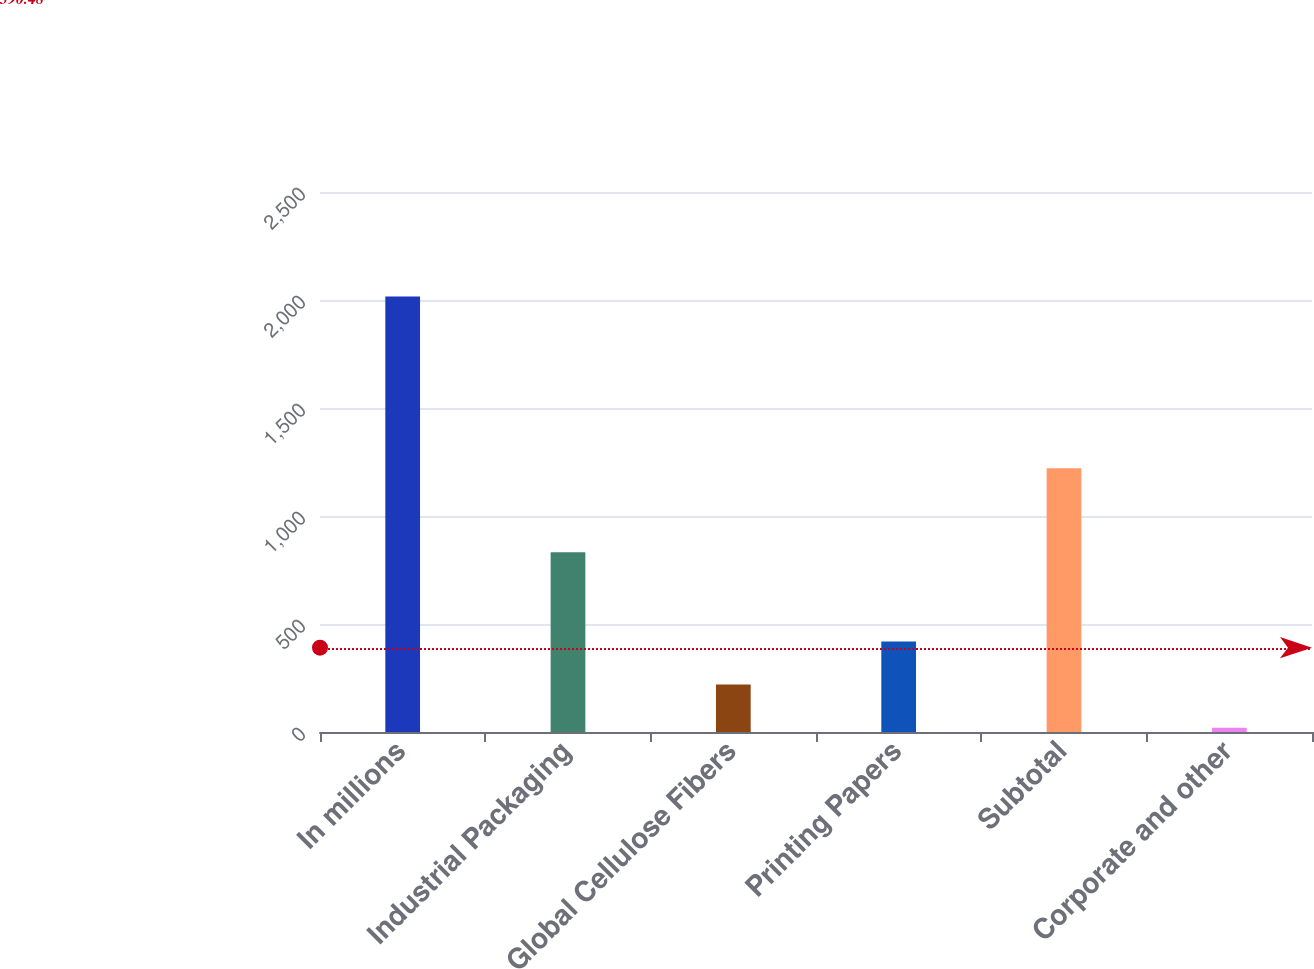<chart> <loc_0><loc_0><loc_500><loc_500><bar_chart><fcel>In millions<fcel>Industrial Packaging<fcel>Global Cellulose Fibers<fcel>Printing Papers<fcel>Subtotal<fcel>Corporate and other<nl><fcel>2016<fcel>832<fcel>219.6<fcel>419.2<fcel>1221<fcel>20<nl></chart> 